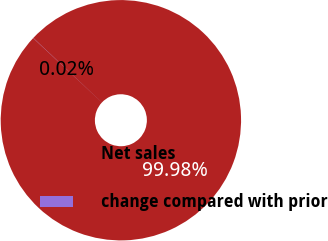Convert chart. <chart><loc_0><loc_0><loc_500><loc_500><pie_chart><fcel>Net sales<fcel>change compared with prior<nl><fcel>99.98%<fcel>0.02%<nl></chart> 